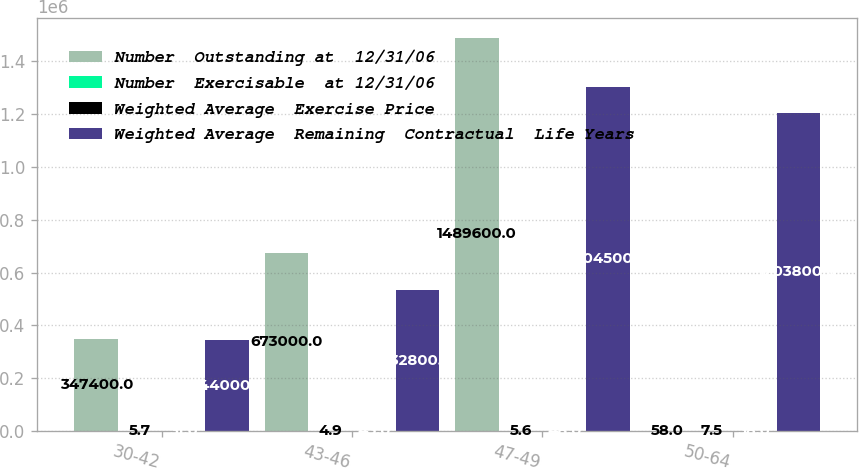<chart> <loc_0><loc_0><loc_500><loc_500><stacked_bar_chart><ecel><fcel>30-42<fcel>43-46<fcel>47-49<fcel>50-64<nl><fcel>Number  Outstanding at  12/31/06<fcel>347400<fcel>673000<fcel>1.4896e+06<fcel>58<nl><fcel>Number  Exercisable  at 12/31/06<fcel>5.7<fcel>4.9<fcel>5.6<fcel>7.5<nl><fcel>Weighted Average  Exercise Price<fcel>31<fcel>45<fcel>48<fcel>58<nl><fcel>Weighted Average  Remaining  Contractual  Life Years<fcel>344000<fcel>532800<fcel>1.3045e+06<fcel>1.2038e+06<nl></chart> 